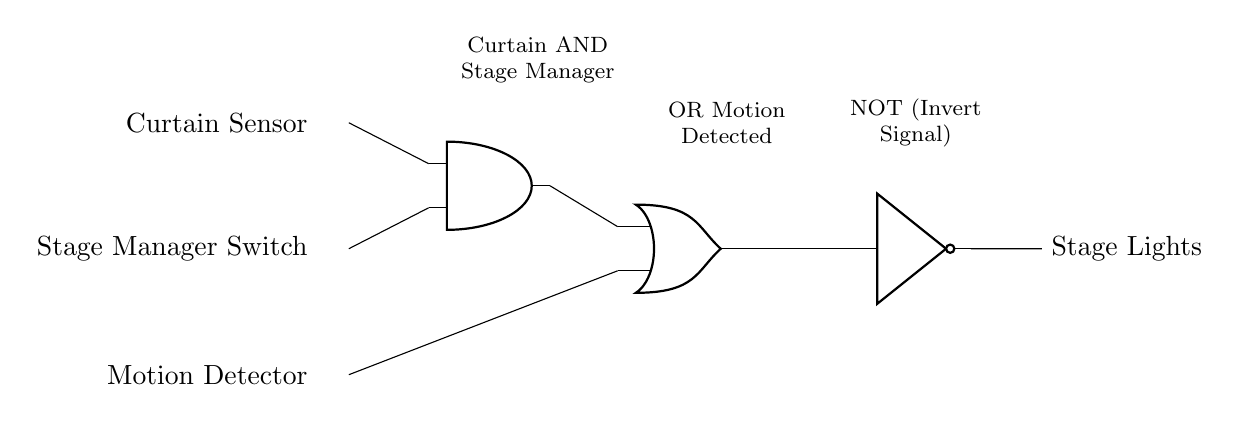What are the inputs to the circuit? The inputs are the Curtain Sensor, Stage Manager Switch, and Motion Detector. They are located on the left side of the diagram.
Answer: Curtain Sensor, Stage Manager Switch, Motion Detector What type of logic gate is used for the first operation? The first operation involves an AND gate, which combines the inputs from the Curtain Sensor and Stage Manager Switch.
Answer: AND gate What is the output of the OR gate? The output of the OR gate will activate the Stage Lights if either the output from the AND gate (Curtain and Stage Manager) or the Motion Detector is activated.
Answer: Stage Lights How does the NOT gate function in this circuit? The NOT gate inverts the signal from the OR gate, meaning that the Stage Lights will turn off if the conditions for the OR gate are met.
Answer: Invert Signal Which combination of inputs turns on the Stage Lights? The Stage Lights will turn on when both the Curtain Sensor and the Stage Manager Switch are activated, or when the Motion Detector is activated.
Answer: Curtain and Stage Manager, or Motion Detector What is the role of the Motion Detector in this circuit? The Motion Detector acts as an alternative trigger along with the AND gate’s output; if motion is detected, it can turn on the Stage Lights independently.
Answer: Alternative trigger 